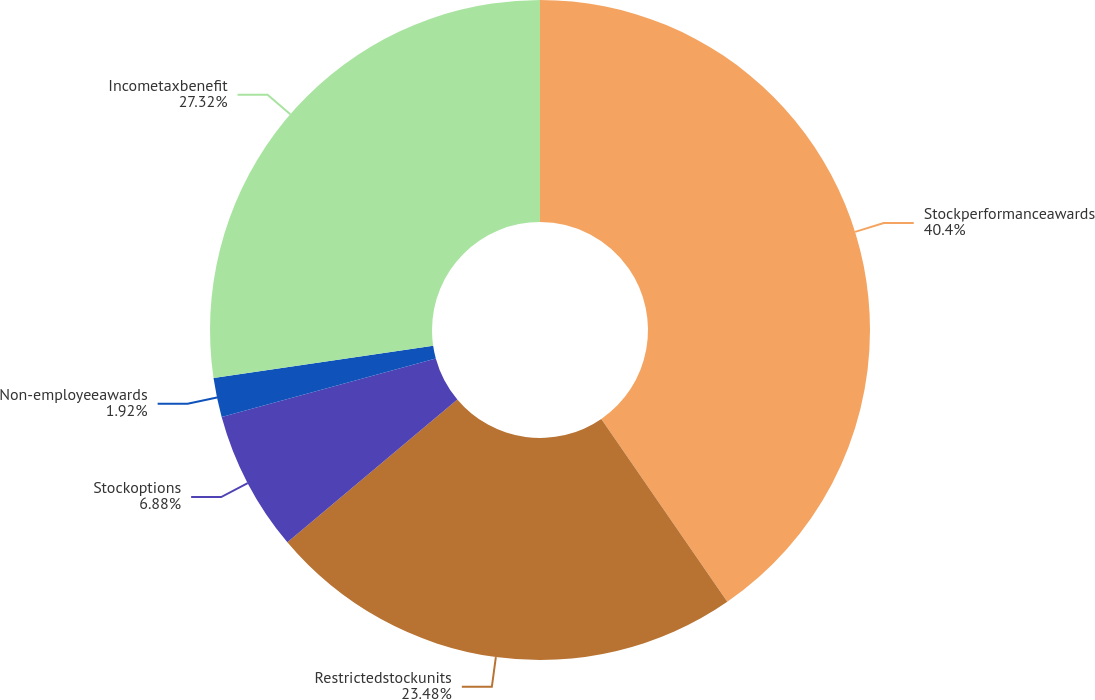Convert chart to OTSL. <chart><loc_0><loc_0><loc_500><loc_500><pie_chart><fcel>Stockperformanceawards<fcel>Restrictedstockunits<fcel>Stockoptions<fcel>Non-employeeawards<fcel>Incometaxbenefit<nl><fcel>40.39%<fcel>23.48%<fcel>6.88%<fcel>1.92%<fcel>27.32%<nl></chart> 